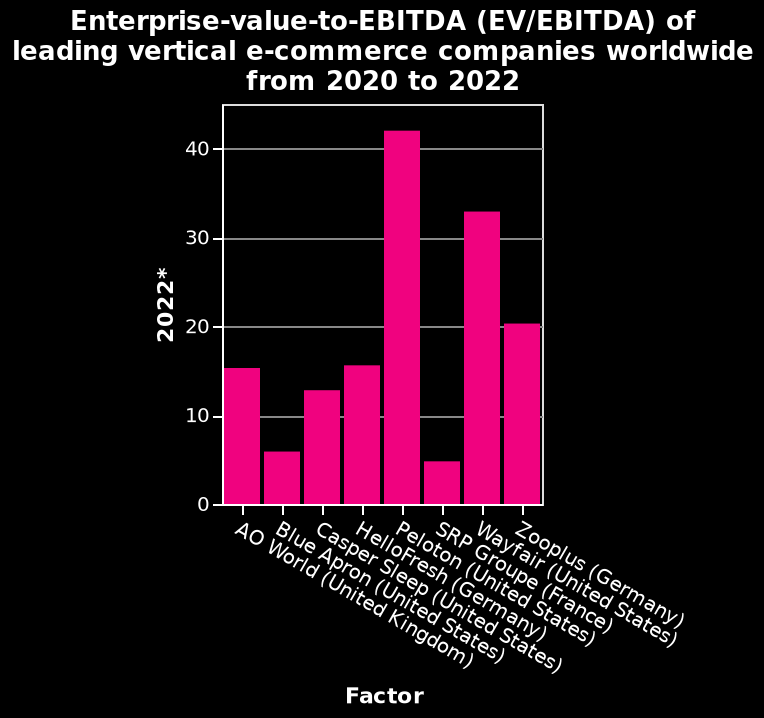<image>
What does the y-axis represent in the bar chart? The y-axis represents "2022*" in the bar chart. What is the title of the bar chart? The title of the bar chart is "Enterprise-value-to-EBITDA (EV/EBITDA) of leading vertical e-commerce companies worldwide from 2020 to 2022." 